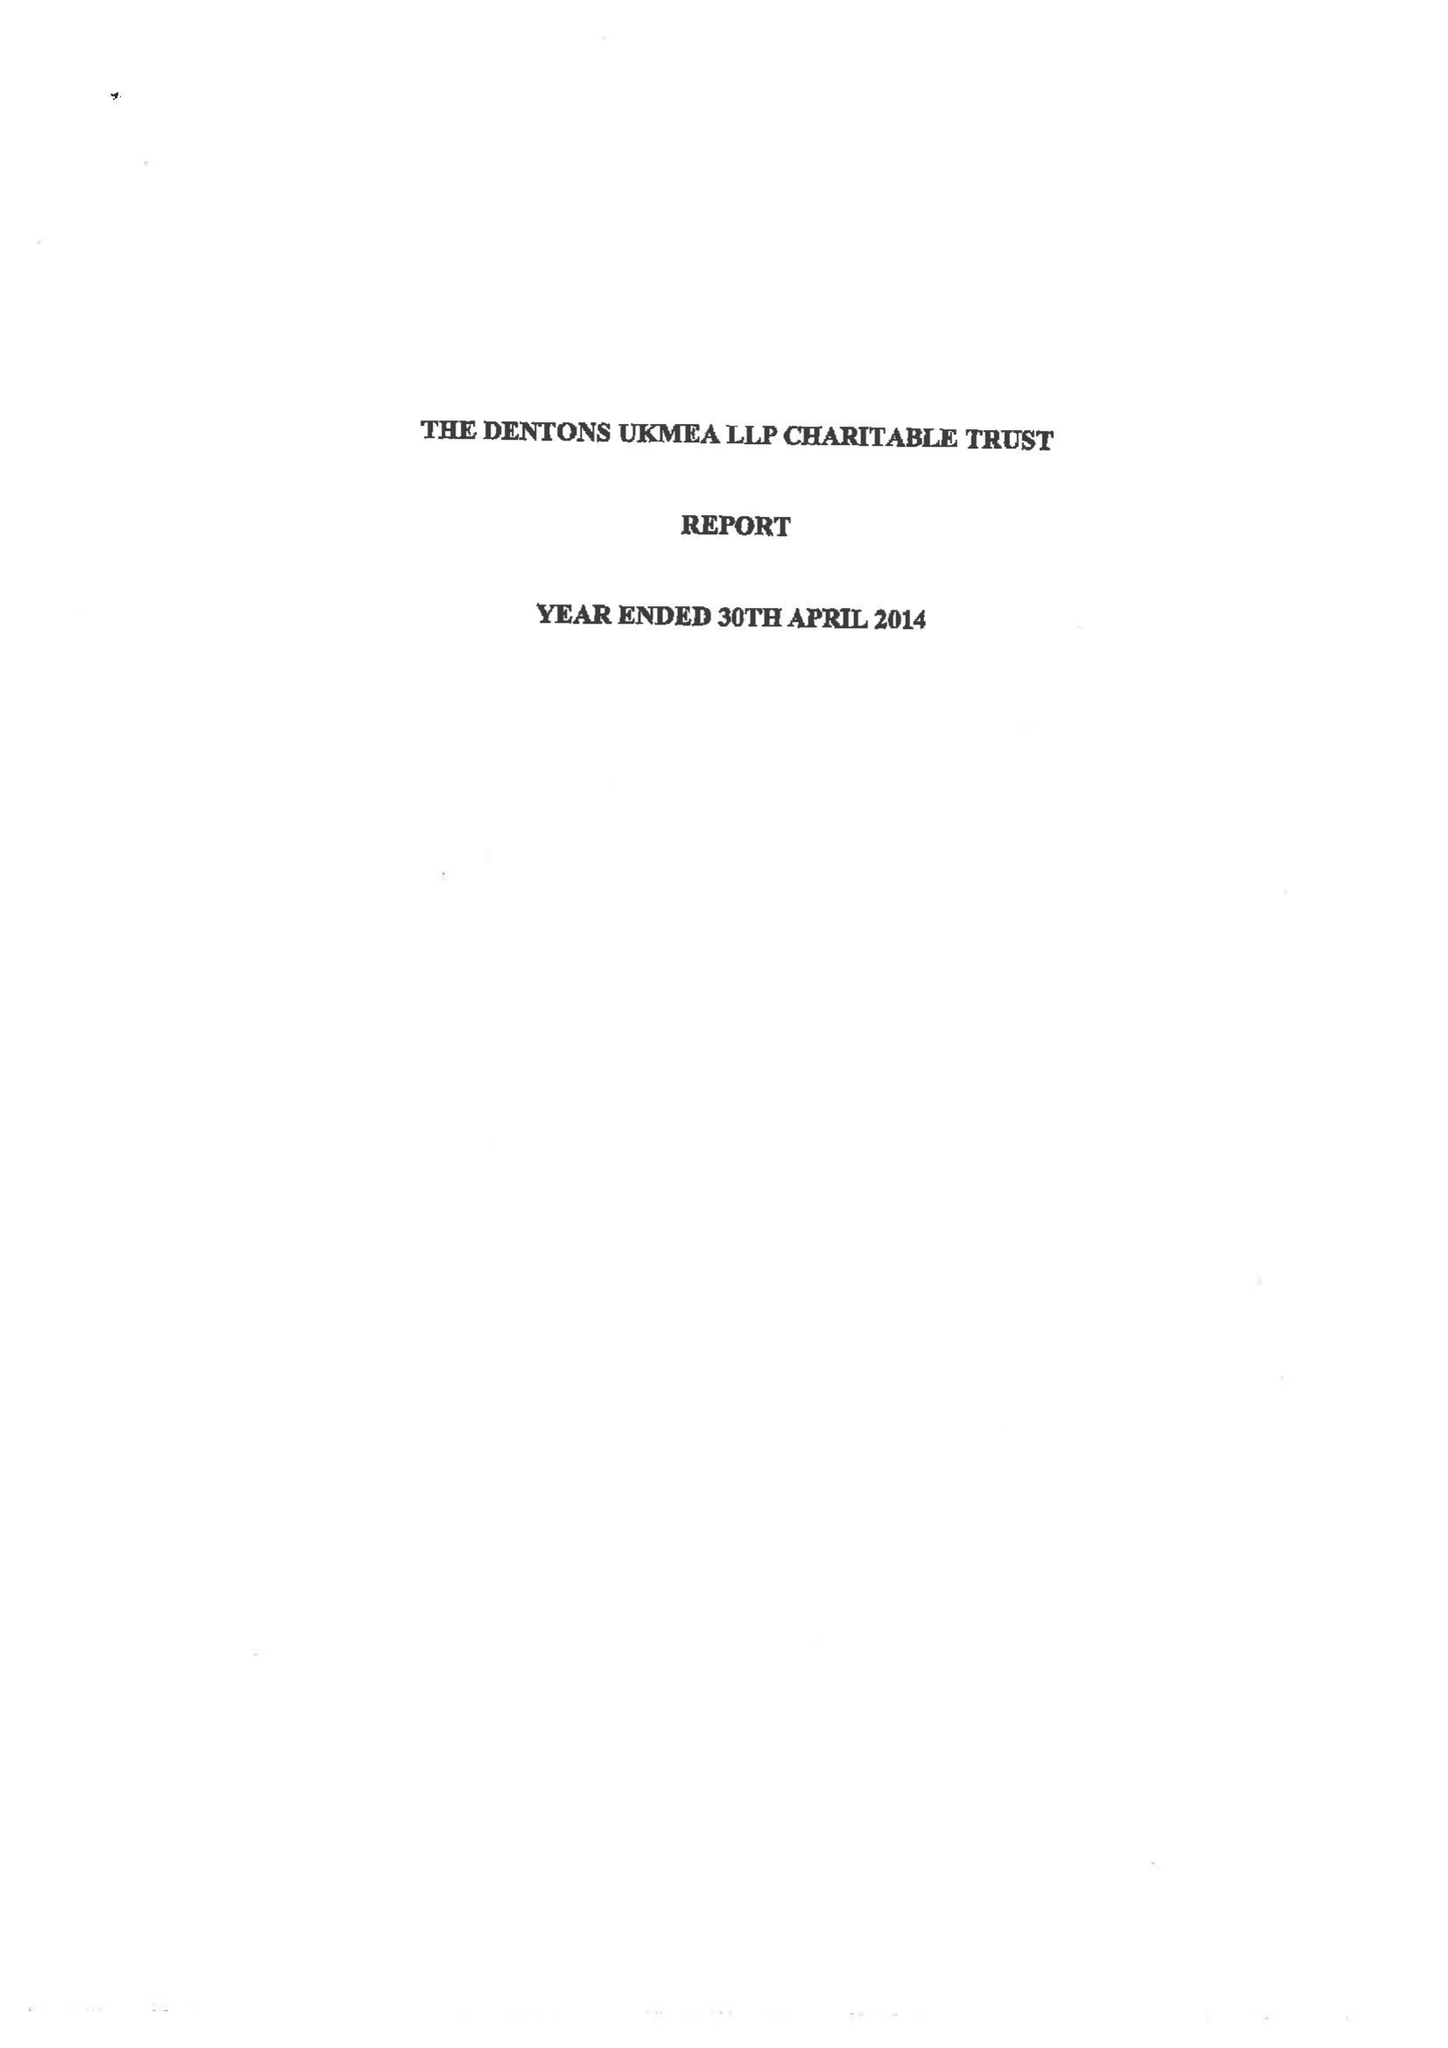What is the value for the address__street_line?
Answer the question using a single word or phrase. None 